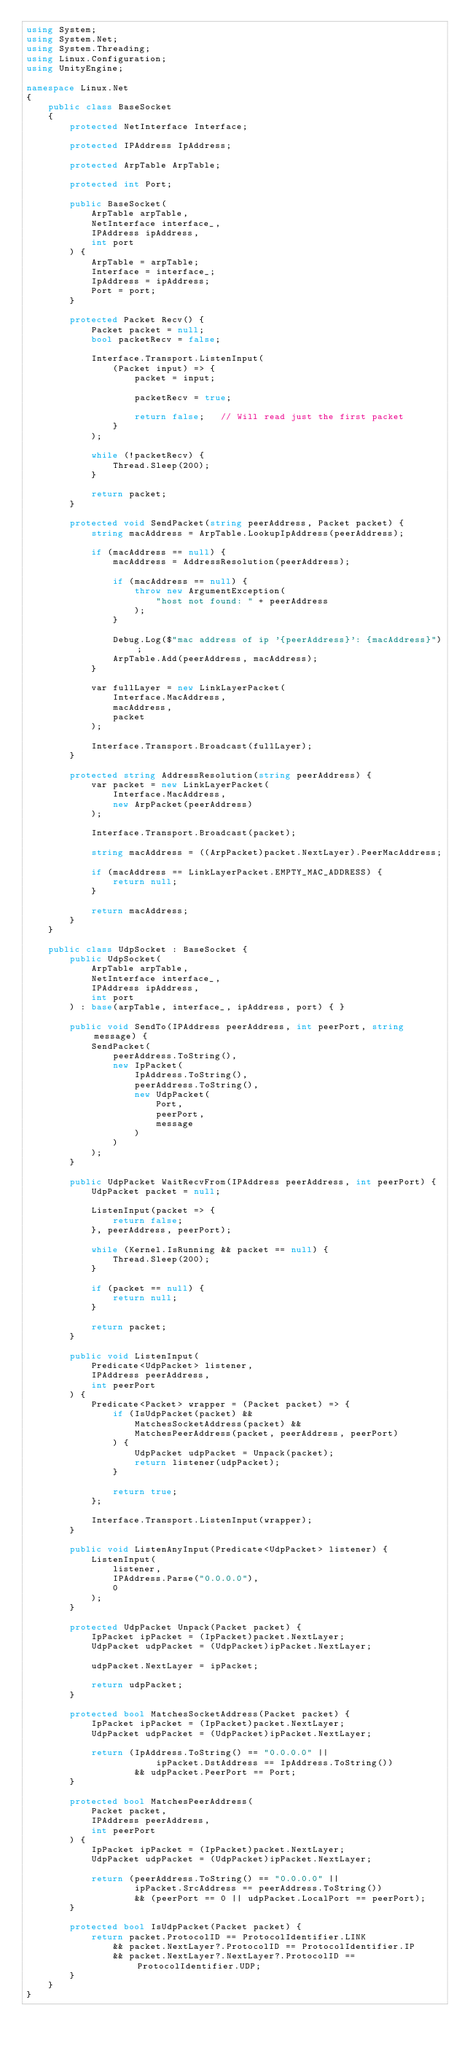Convert code to text. <code><loc_0><loc_0><loc_500><loc_500><_C#_>using System;
using System.Net;
using System.Threading;
using Linux.Configuration;
using UnityEngine;

namespace Linux.Net
{
    public class BaseSocket
    {
        protected NetInterface Interface;

        protected IPAddress IpAddress;

        protected ArpTable ArpTable;

        protected int Port;

        public BaseSocket(
            ArpTable arpTable,
            NetInterface interface_,
            IPAddress ipAddress,
            int port
        ) {
            ArpTable = arpTable;
            Interface = interface_;
            IpAddress = ipAddress;
            Port = port;
        }

        protected Packet Recv() {
            Packet packet = null;
            bool packetRecv = false;

            Interface.Transport.ListenInput(
                (Packet input) => {
                    packet = input;

                    packetRecv = true;

                    return false;   // Will read just the first packet
                }
            );

            while (!packetRecv) {
                Thread.Sleep(200);
            }

            return packet;
        }

        protected void SendPacket(string peerAddress, Packet packet) {
            string macAddress = ArpTable.LookupIpAddress(peerAddress);

            if (macAddress == null) {
                macAddress = AddressResolution(peerAddress);

                if (macAddress == null) {
                    throw new ArgumentException(
                        "host not found: " + peerAddress
                    );
                }

                Debug.Log($"mac address of ip '{peerAddress}': {macAddress}");
                ArpTable.Add(peerAddress, macAddress);
            }

            var fullLayer = new LinkLayerPacket(
                Interface.MacAddress,
                macAddress,
                packet
            );

            Interface.Transport.Broadcast(fullLayer);
        }

        protected string AddressResolution(string peerAddress) {
            var packet = new LinkLayerPacket(
                Interface.MacAddress,
                new ArpPacket(peerAddress)
            );
            
            Interface.Transport.Broadcast(packet);

            string macAddress = ((ArpPacket)packet.NextLayer).PeerMacAddress;

            if (macAddress == LinkLayerPacket.EMPTY_MAC_ADDRESS) {
                return null;
            }

            return macAddress;
        }
    }

    public class UdpSocket : BaseSocket {
        public UdpSocket(
            ArpTable arpTable,
            NetInterface interface_,
            IPAddress ipAddress, 
            int port
        ) : base(arpTable, interface_, ipAddress, port) { }

        public void SendTo(IPAddress peerAddress, int peerPort, string message) {
            SendPacket(
                peerAddress.ToString(),
                new IpPacket(
                    IpAddress.ToString(),
                    peerAddress.ToString(),
                    new UdpPacket(
                        Port,
                        peerPort,
                        message
                    )
                )
            );
        }

        public UdpPacket WaitRecvFrom(IPAddress peerAddress, int peerPort) {
            UdpPacket packet = null;

            ListenInput(packet => {
                return false;
            }, peerAddress, peerPort);

            while (Kernel.IsRunning && packet == null) {
                Thread.Sleep(200);
            }

            if (packet == null) {
                return null;
            }

            return packet;
        }

        public void ListenInput(
            Predicate<UdpPacket> listener,
            IPAddress peerAddress,
            int peerPort
        ) {
            Predicate<Packet> wrapper = (Packet packet) => {
                if (IsUdpPacket(packet) &&
                    MatchesSocketAddress(packet) &&
                    MatchesPeerAddress(packet, peerAddress, peerPort)
                ) {
                    UdpPacket udpPacket = Unpack(packet);
                    return listener(udpPacket);
                }

                return true;
            };

            Interface.Transport.ListenInput(wrapper);
        }

        public void ListenAnyInput(Predicate<UdpPacket> listener) {
            ListenInput(
                listener,
                IPAddress.Parse("0.0.0.0"),
                0
            );
        }

        protected UdpPacket Unpack(Packet packet) {
            IpPacket ipPacket = (IpPacket)packet.NextLayer;
            UdpPacket udpPacket = (UdpPacket)ipPacket.NextLayer;

            udpPacket.NextLayer = ipPacket;

            return udpPacket;
        }

        protected bool MatchesSocketAddress(Packet packet) {
            IpPacket ipPacket = (IpPacket)packet.NextLayer;
            UdpPacket udpPacket = (UdpPacket)ipPacket.NextLayer;

            return (IpAddress.ToString() == "0.0.0.0" ||
                        ipPacket.DstAddress == IpAddress.ToString())
                    && udpPacket.PeerPort == Port;
        }

        protected bool MatchesPeerAddress(
            Packet packet,
            IPAddress peerAddress,
            int peerPort
        ) {
            IpPacket ipPacket = (IpPacket)packet.NextLayer;
            UdpPacket udpPacket = (UdpPacket)ipPacket.NextLayer;

            return (peerAddress.ToString() == "0.0.0.0" ||
                    ipPacket.SrcAddress == peerAddress.ToString())
                    && (peerPort == 0 || udpPacket.LocalPort == peerPort);
        }

        protected bool IsUdpPacket(Packet packet) {
            return packet.ProtocolID == ProtocolIdentifier.LINK
                && packet.NextLayer?.ProtocolID == ProtocolIdentifier.IP
                && packet.NextLayer?.NextLayer?.ProtocolID == ProtocolIdentifier.UDP;
        }
    }
}</code> 